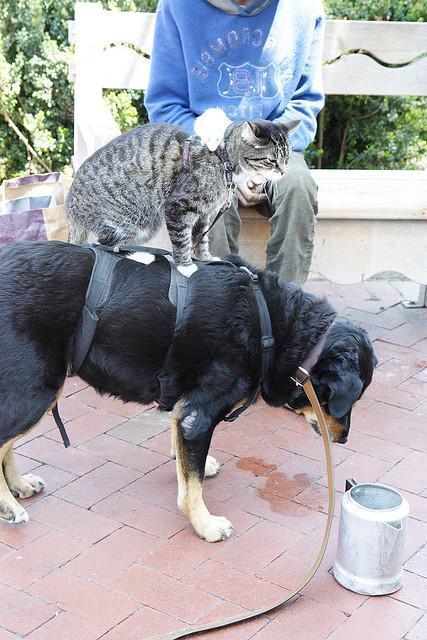How many animals are there?
Give a very brief answer. 2. How many cats can you see?
Give a very brief answer. 1. How many boats do you see in this picture?
Give a very brief answer. 0. 